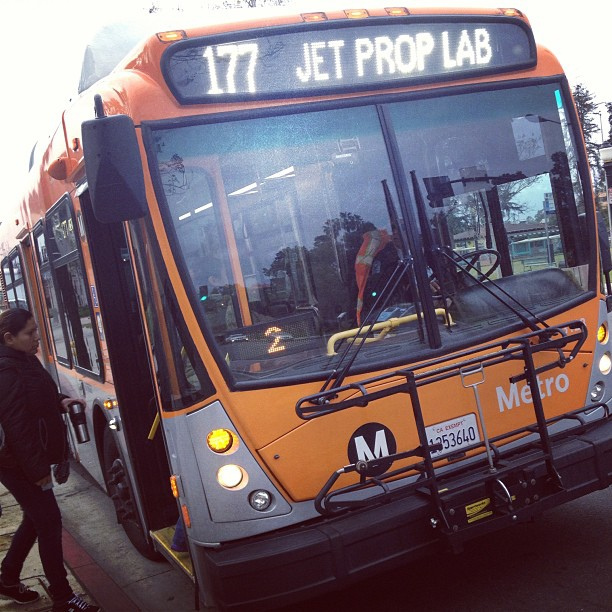Identify the text contained in this image. 177 JET PORP LAB Metro 1353640 M 2 